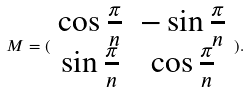<formula> <loc_0><loc_0><loc_500><loc_500>M = ( \begin{array} { c c } \cos \frac { \pi } { n } & - \sin \frac { \pi } { n } \\ \sin \frac { \pi } { n } & \cos \frac { \pi } { n } \end{array} ) .</formula> 